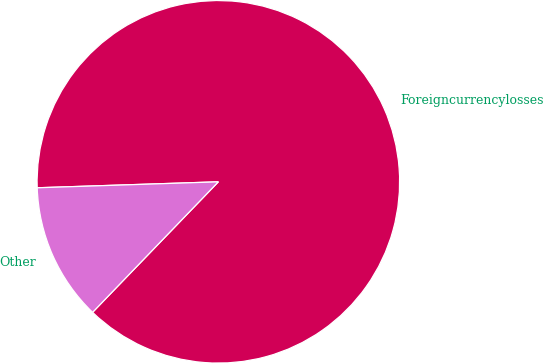<chart> <loc_0><loc_0><loc_500><loc_500><pie_chart><fcel>Foreigncurrencylosses<fcel>Other<nl><fcel>87.73%<fcel>12.27%<nl></chart> 